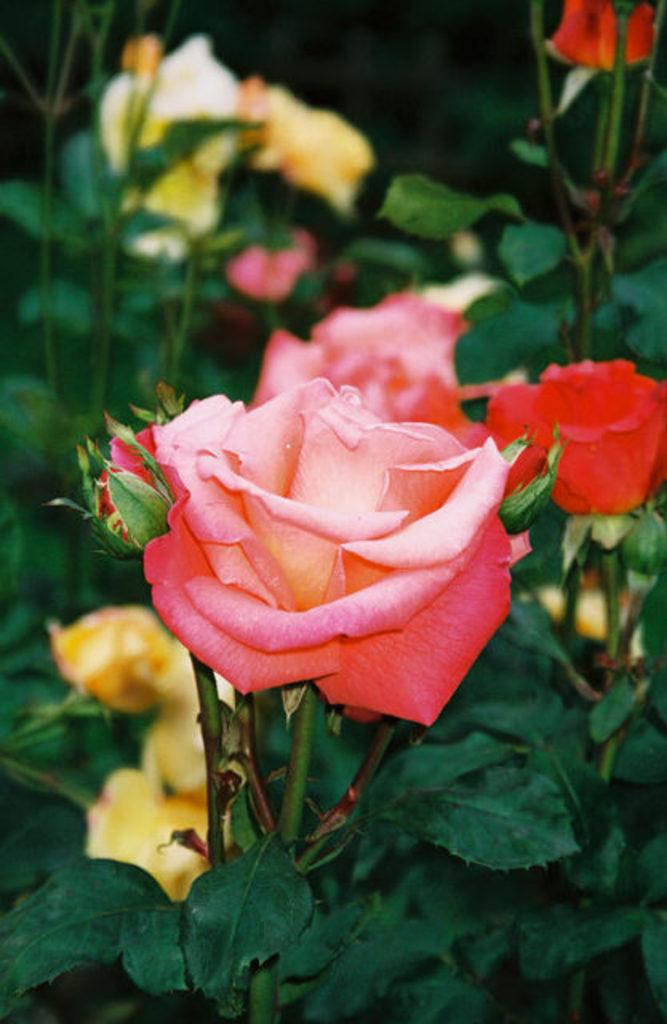What type of flowers can be seen in the image? There are rose flowers in the image. What else is present in the image besides the flowers? There are leaves in the image. Can you describe the background of the image? The background of the image is blurry. How does the gun affect the digestion process in the image? There is no gun present in the image, so it cannot affect the digestion process. 